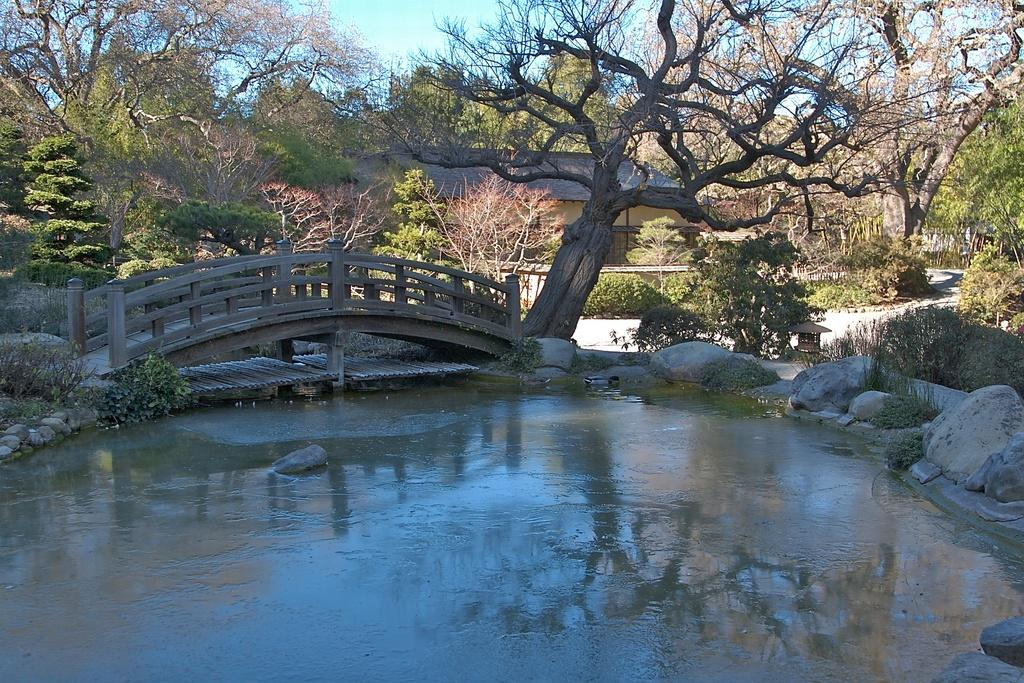What type of structure is present in the image? There is a foot over bridge in the image. Where is the foot over bridge positioned? The foot over bridge is positioned over a pond. What type of natural elements can be seen in the image? Rocks, shrubs, bushes, plants, and trees are present in the image. What type of man-made structures can be seen in the image? There are buildings in the image. What is visible in the sky in the image? The sky is visible in the image, and clouds are present in the sky. Can you see any roses growing near the foot over bridge in the image? There are no roses visible in the image. Is there any soda being consumed by people in the image? There is no indication of soda or people consuming it in the image. Is there any quicksand present in the image? There is no quicksand present in the image. 